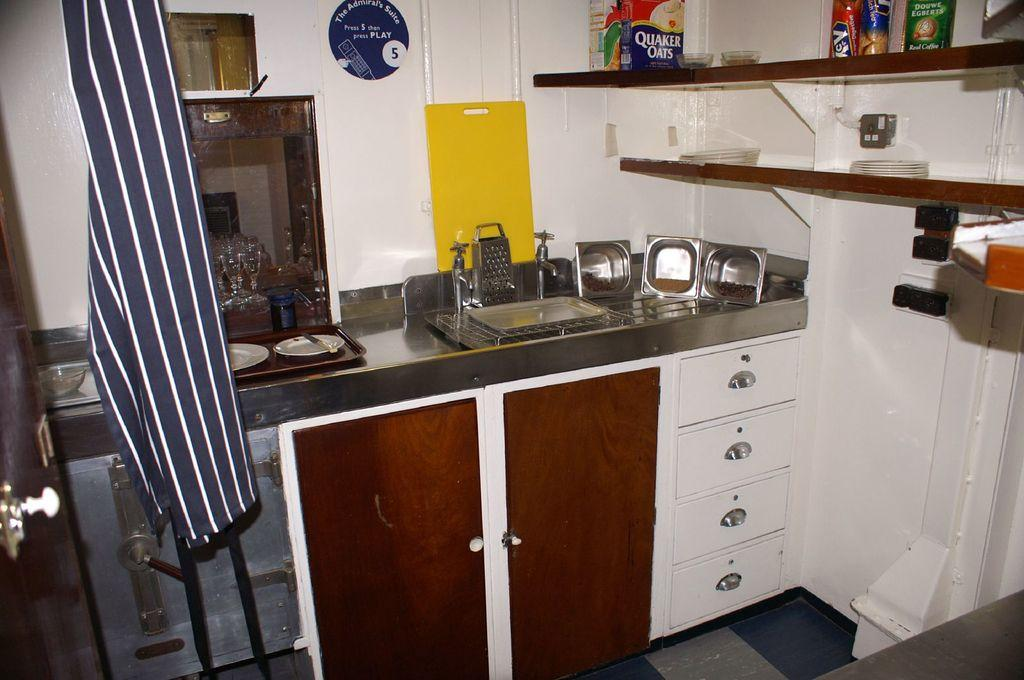<image>
Give a short and clear explanation of the subsequent image. A box of Quaker Oats is on the shelf in an orderly kitchen. 